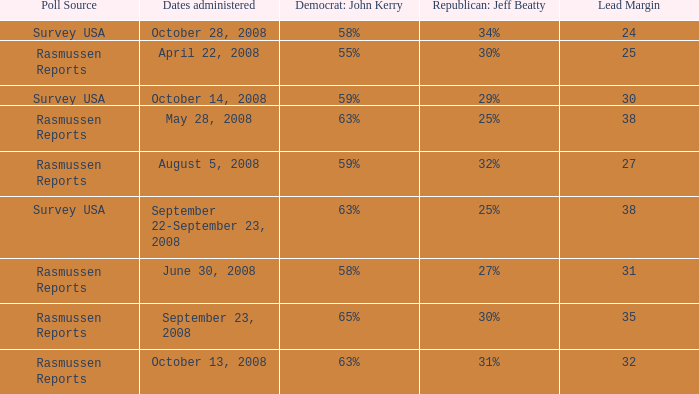What is the percentage for john kerry and dates administered is april 22, 2008? 55%. 